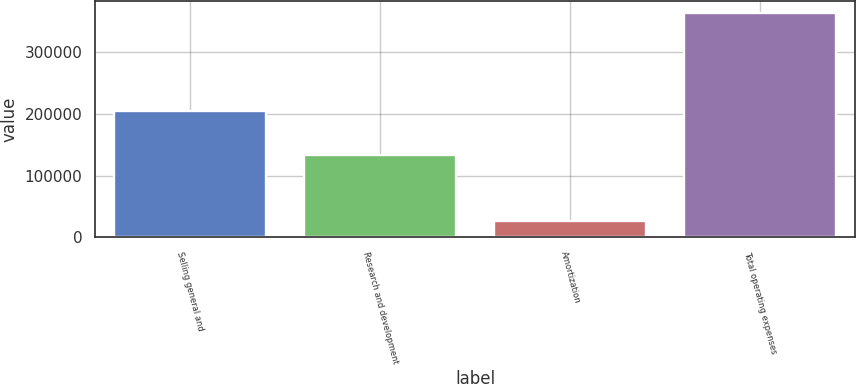Convert chart. <chart><loc_0><loc_0><loc_500><loc_500><bar_chart><fcel>Selling general and<fcel>Research and development<fcel>Amortization<fcel>Total operating expenses<nl><fcel>205178<fcel>132628<fcel>26443<fcel>364249<nl></chart> 